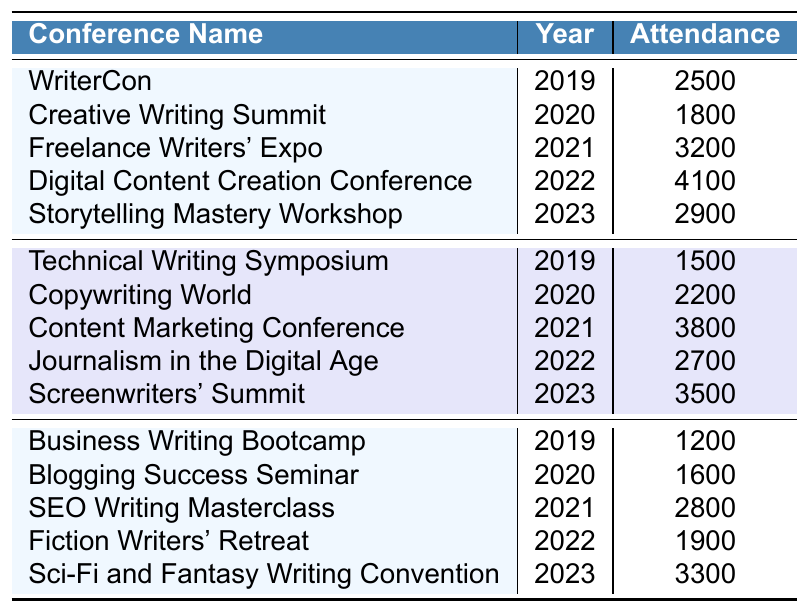What was the attendance at the Freelance Writers' Expo? The table shows that the Freelance Writers' Expo, held in 2021, had an attendance of 3200.
Answer: 3200 What is the attendance of the Digital Content Creation Conference? The table lists the attendance for the Digital Content Creation Conference in 2022 as 4100.
Answer: 4100 Which writing conference had the highest attendance? By comparing the attendance figures, the Digital Content Creation Conference had the highest attendance with 4100.
Answer: 4100 How many conferences took place in 2020? There are two conferences listed for 2020: the Creative Writing Summit and Copywriting World.
Answer: 2 What was the total attendance for all conferences in 2019? The total attendance for 2019 can be calculated by adding the attendance figures: 2500 (WriterCon) + 1500 (Technical Writing Symposium) + 1200 (Business Writing Bootcamp) = 5200.
Answer: 5200 What is the average attendance in 2021? The attendance figures for 2021 are 3200 (Freelance Writers' Expo), 3800 (Content Marketing Conference), and 2800 (SEO Writing Masterclass). The average is (3200 + 3800 + 2800) / 3 = 3266.67.
Answer: 3266.67 Is the attendance at the Blogging Success Seminar less than 1800? The attendance at the Blogging Success Seminar is 1600, which is less than 1800.
Answer: Yes What difference in attendance exists between the highest and lowest attended conferences in 2023? The highest attendance in 2023 is 3500 (Screenwriters' Summit) and the lowest is 2900 (Storytelling Mastery Workshop). The difference is 3500 - 2900 = 600.
Answer: 600 What was the percentage increase in attendance from the Creative Writing Summit in 2020 to the Digital Content Creation Conference in 2022? The attendance for the Creative Writing Summit is 1800 and for the Digital Content Creation Conference is 4100. The increase is 4100 - 1800 = 2300. The percentage increase is (2300 / 1800) * 100 = 127.78%.
Answer: 127.78% Are there more conferences with attendance over 3000 than under 2000? The conferences with attendance over 3000 are the Freelance Writers' Expo (3200), Digital Content Creation Conference (4100), Content Marketing Conference (3800), and Screenwriters' Summit (3500), totaling 4. The ones under 2000 are Technical Writing Symposium (1500), Business Writing Bootcamp (1200), Blogging Success Seminar (1600), and Fiction Writers' Retreat (1900), totaling 4 as well. Therefore, there is an equal number of both.
Answer: No 